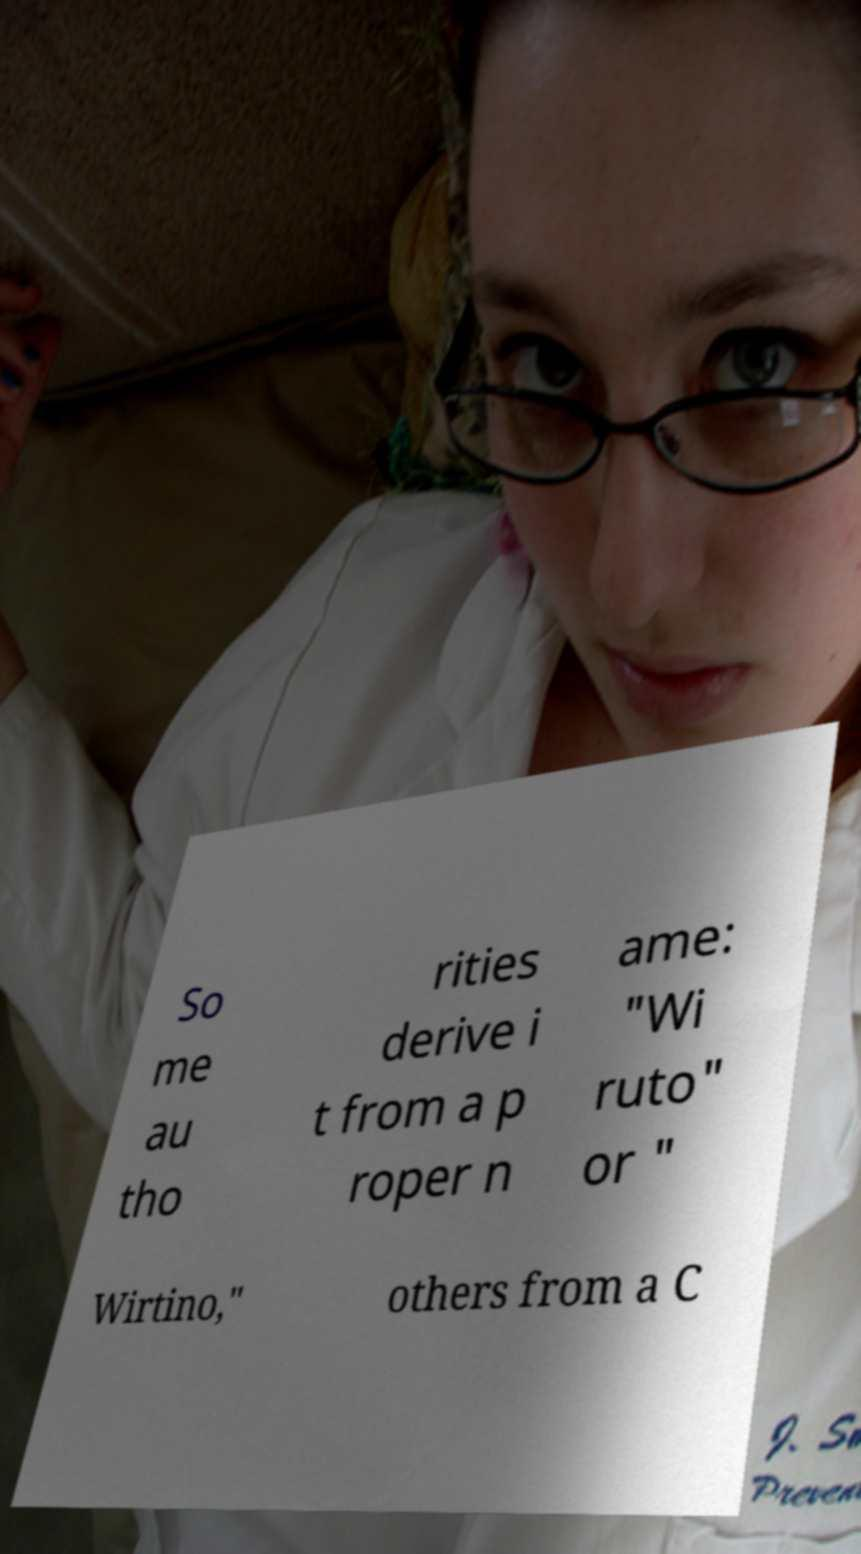Could you assist in decoding the text presented in this image and type it out clearly? So me au tho rities derive i t from a p roper n ame: "Wi ruto" or " Wirtino," others from a C 